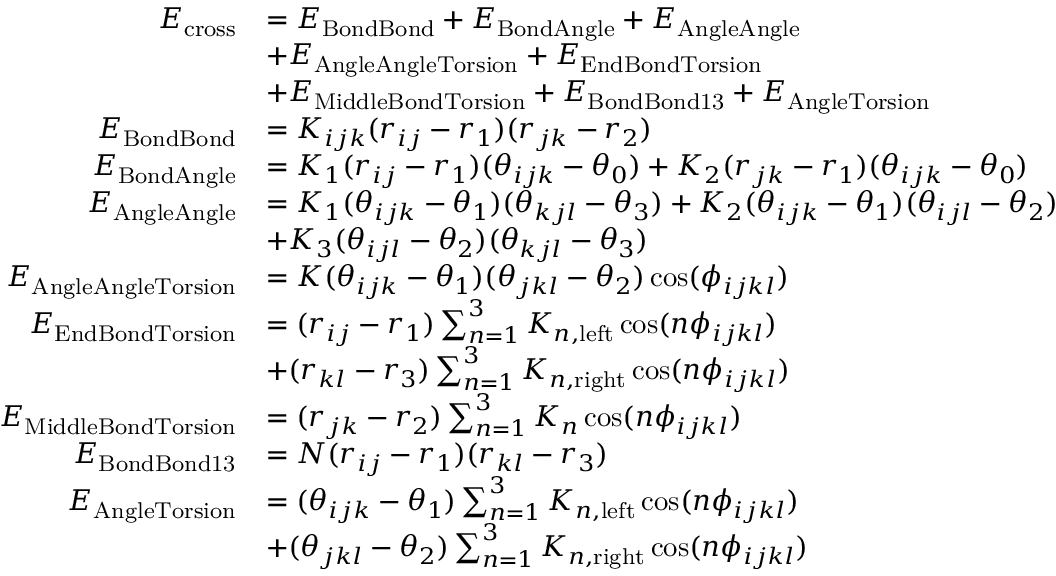<formula> <loc_0><loc_0><loc_500><loc_500>\begin{array} { r l } { E _ { c r o s s } } & { = E _ { B o n d B o n d } + E _ { B o n d A n g l e } + E _ { A n g l e A n g l e } } \\ & { + E _ { A n g l e A n g l e T o r s i o n } + E _ { E n d B o n d T o r s i o n } } \\ & { + E _ { M i d d l e B o n d T o r s i o n } + E _ { B o n d B o n d 1 3 } + E _ { A n g l e T o r s i o n } } \\ { E _ { B o n d B o n d } } & { = K _ { i j k } ( r _ { i j } - r _ { 1 } ) ( r _ { j k } - r _ { 2 } ) } \\ { E _ { B o n d A n g l e } } & { = K _ { 1 } ( r _ { i j } - r _ { 1 } ) ( \theta _ { i j k } - \theta _ { 0 } ) + K _ { 2 } ( r _ { j k } - r _ { 1 } ) ( \theta _ { i j k } - \theta _ { 0 } ) } \\ { E _ { A n g l e A n g l e } } & { = K _ { 1 } ( \theta _ { i j k } - \theta _ { 1 } ) ( \theta _ { k j l } - \theta _ { 3 } ) + K _ { 2 } ( \theta _ { i j k } - \theta _ { 1 } ) ( \theta _ { i j l } - \theta _ { 2 } ) } \\ & { + K _ { 3 } ( \theta _ { i j l } - \theta _ { 2 } ) ( \theta _ { k j l } - \theta _ { 3 } ) } \\ { E _ { A n g l e A n g l e T o r s i o n } } & { = K ( \theta _ { i j k } - \theta _ { 1 } ) ( \theta _ { j k l } - \theta _ { 2 } ) \cos ( \phi _ { i j k l } ) } \\ { E _ { E n d B o n d T o r s i o n } } & { = ( r _ { i j } - r _ { 1 } ) \sum _ { n = 1 } ^ { 3 } K _ { n , l e f t } \cos ( n \phi _ { i j k l } ) } \\ & { + ( r _ { k l } - r _ { 3 } ) \sum _ { n = 1 } ^ { 3 } K _ { n , r i g h t } \cos ( n \phi _ { i j k l } ) } \\ { E _ { M i d d l e B o n d T o r s i o n } } & { = ( r _ { j k } - r _ { 2 } ) \sum _ { n = 1 } ^ { 3 } K _ { n } \cos ( n \phi _ { i j k l } ) } \\ { E _ { B o n d B o n d 1 3 } } & { = N ( r _ { i j } - r _ { 1 } ) ( r _ { k l } - r _ { 3 } ) } \\ { E _ { A n g l e T o r s i o n } } & { = ( \theta _ { i j k } - \theta _ { 1 } ) \sum _ { n = 1 } ^ { 3 } K _ { n , l e f t } \cos ( n \phi _ { i j k l } ) } \\ & { + ( \theta _ { j k l } - \theta _ { 2 } ) \sum _ { n = 1 } ^ { 3 } K _ { n , r i g h t } \cos ( n \phi _ { i j k l } ) } \end{array}</formula> 